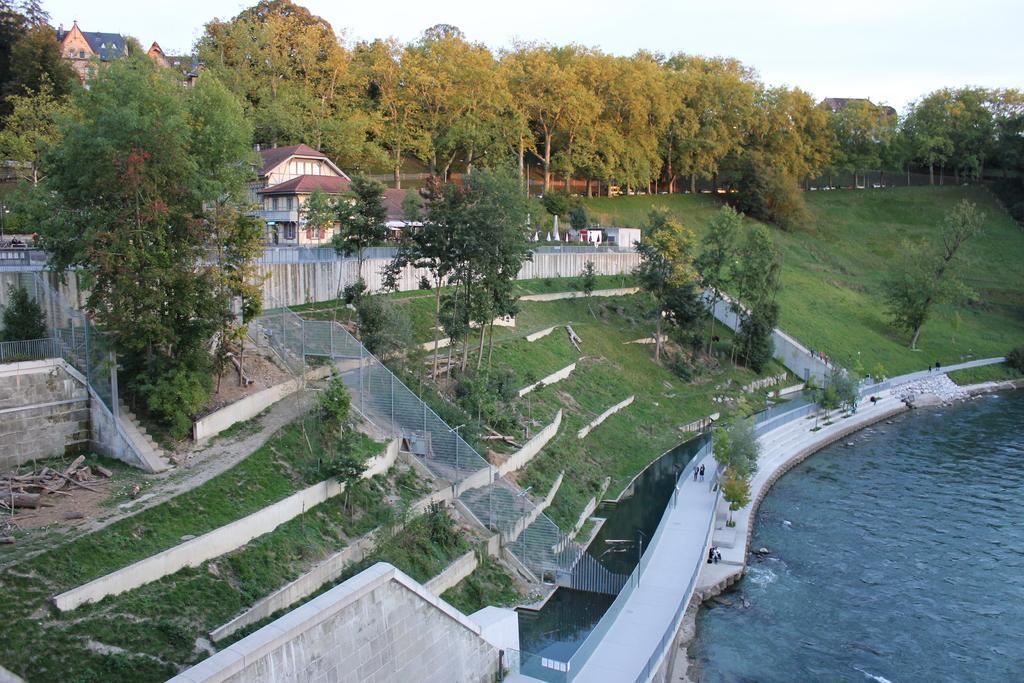Can you describe this image briefly? In this picture we can see beautiful view of the house. In the front we can see roof tile house on the hill. Behind we can see many trees. In the bottom down side we can see fencing iron railing on the hill and a water pound. 